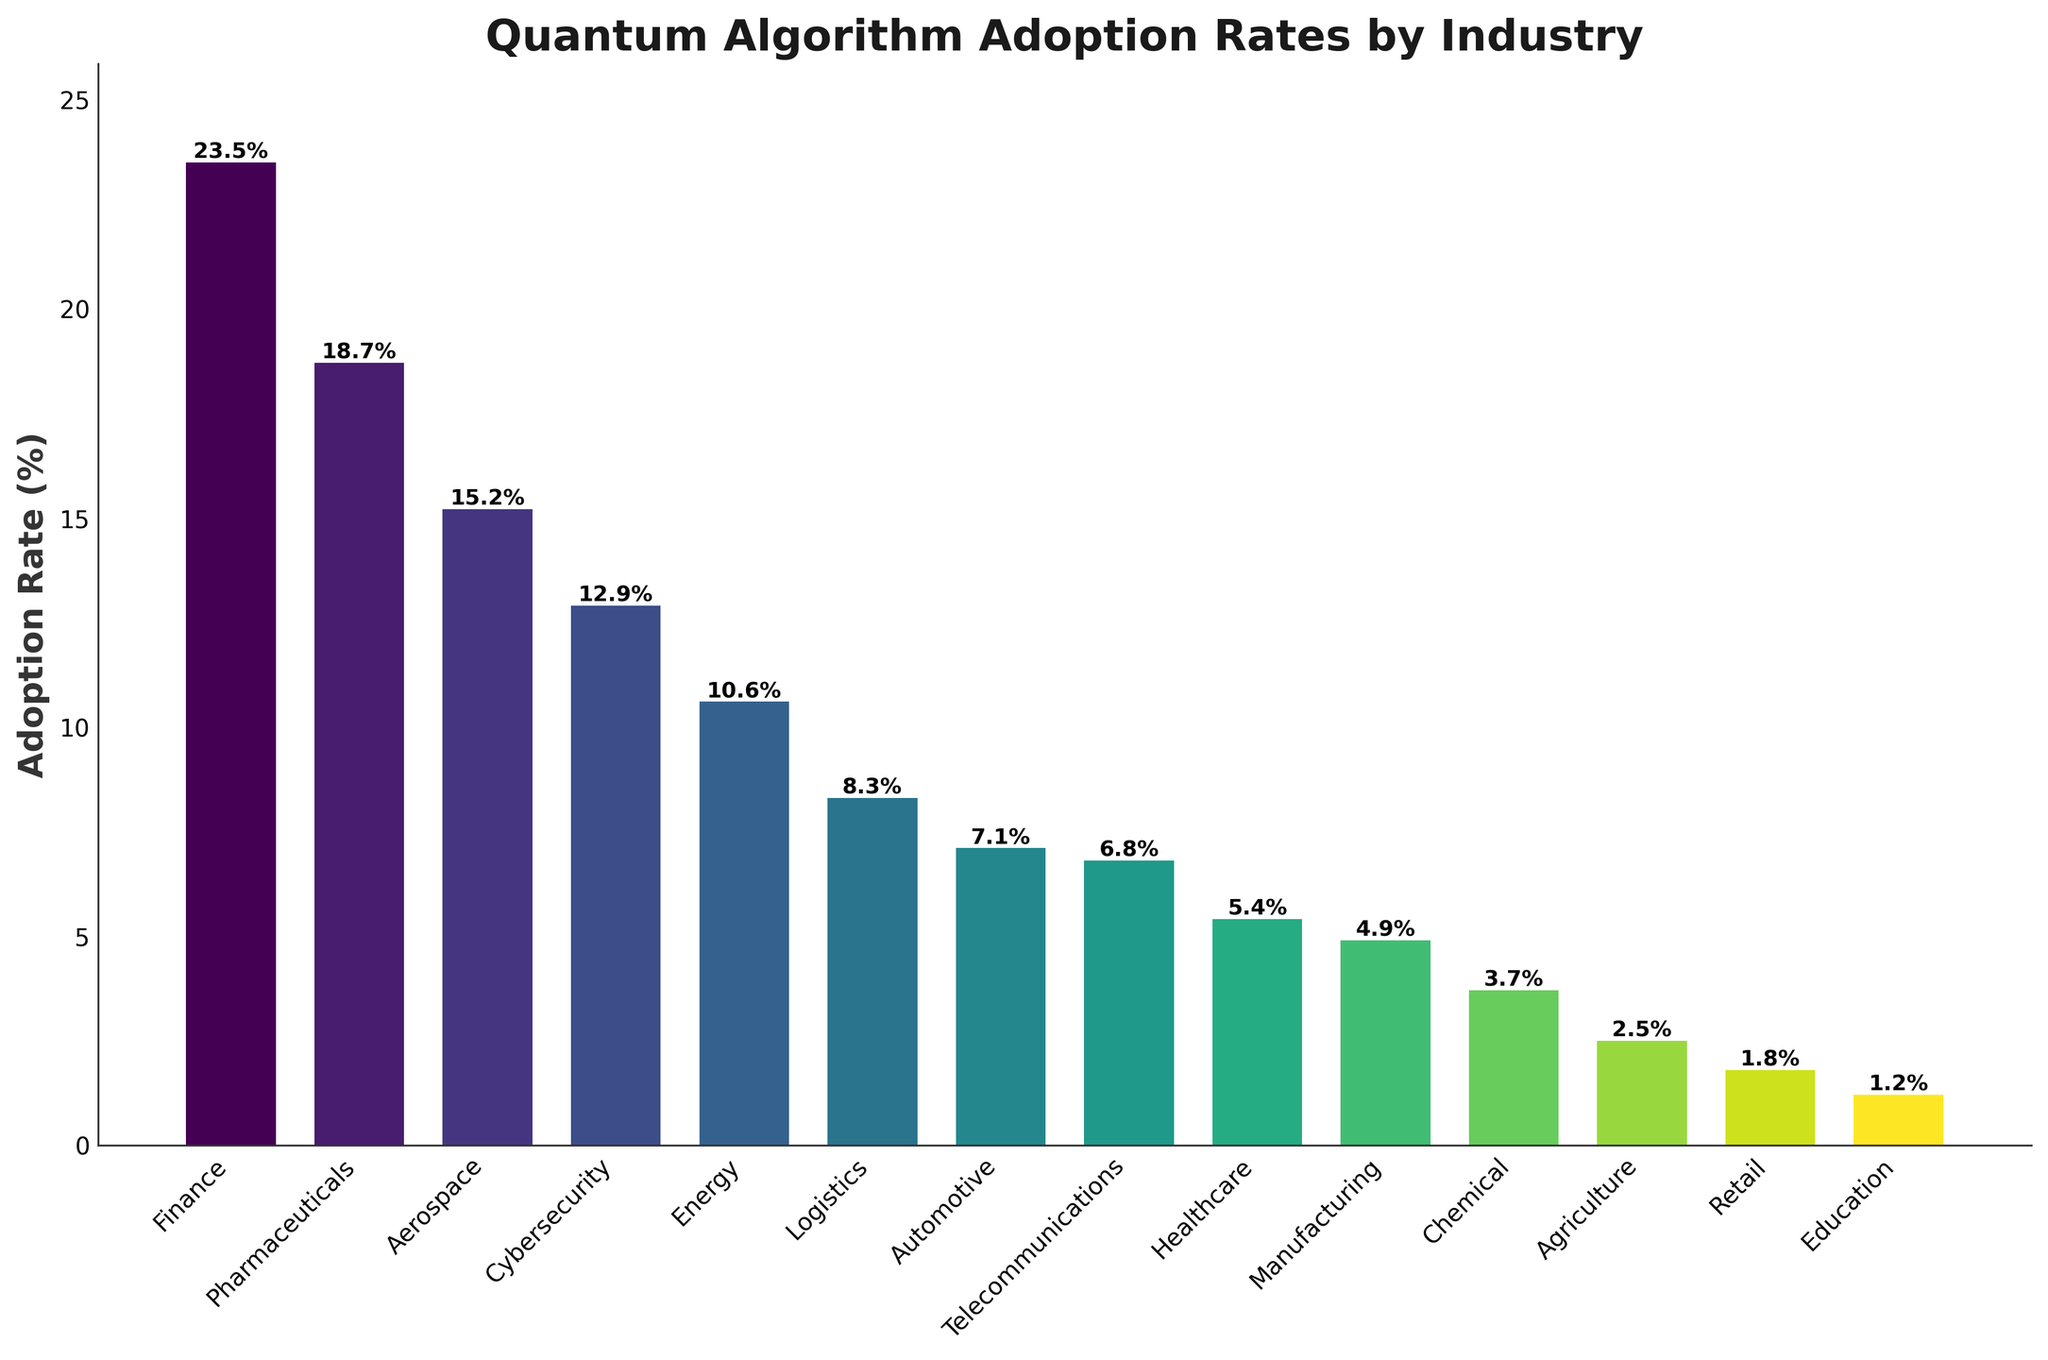What's the industry with the highest adoption rate of quantum algorithms? The figure shows the adoption rates of quantum algorithms for different industries. By looking at the highest bar, we can see that the finance industry has the highest adoption rate at 23.5%.
Answer: Finance What is the difference in adoption rates between the finance and retail industries? The adoption rate for finance is 23.5%, and for retail, it is 1.8%. Subtracting the adoption rate for retail from finance gives us 23.5% - 1.8% = 21.7%.
Answer: 21.7% Which industries have adoption rates greater than 10%? The figure shows the adoption rates for different industries. The bars representing finance (23.5%), pharmaceuticals (18.7%), aerospace (15.2%), cybersecurity (12.9%), and energy (10.6%) are all greater than 10%.
Answer: Finance, Pharmaceuticals, Aerospace, Cybersecurity, Energy What is the average adoption rate for telecommunications, healthcare, and manufacturing? The adoption rates for telecommunications, healthcare, and manufacturing are 6.8%, 5.4%, and 4.9%, respectively. Adding these rates and dividing by 3 gives us (6.8 + 5.4 + 4.9)/3 = 5.7%.
Answer: 5.7% What is the total adoption rate for agriculture, retail, and education combined? The adoption rates for agriculture, retail, and education are 2.5%, 1.8%, and 1.2%, respectively. Adding these rates gives us 2.5% + 1.8% + 1.2% = 5.5%.
Answer: 5.5% Which industry has a bar colored most differently from that of the healthcare industry when considering color gradients? The bars in the figure use a color gradient. Healthcare, which has a relatively lower adoption rate, is towards the end of the gradient. The industry with the highest adoption rate (finance) is colored most differently on the other end of the gradient.
Answer: Finance What is the median adoption rate among the listed industries? To find the median, we first need to order the rates: 1.2%, 1.8%, 2.5%, 3.7%, 4.9%, 5.4%, 6.8%, 7.1%, 8.3%, 10.6%, 12.9%, 15.2%, 18.7%, and 23.5%. The median is the middle value, which is the average of the 7th and 8th values: (6.8% + 7.1%)/2 = 6.95%.
Answer: 6.95% What percentage of industries have adoption rates below 10%? There are 14 industries in total. The industries with adoption rates below 10% are logistics, automotive, telecommunications, healthcare, manufacturing, chemical, and agriculture, accounting for 7 industries. Therefore, (7/14) * 100% = 50%.
Answer: 50% Which two industries have the most similar adoption rates? By examining the bars, telecommunications and automotive have similar heights indicating similar rates: 6.8% for telecommunications and 7.1% for automotive.
Answer: Telecommunications and Automotive In which range do the majority of adoption rates fall? By observing the distribution of the bars, the majority of adoption rates fall within the 0%-10% range.
Answer: 0%-10% 